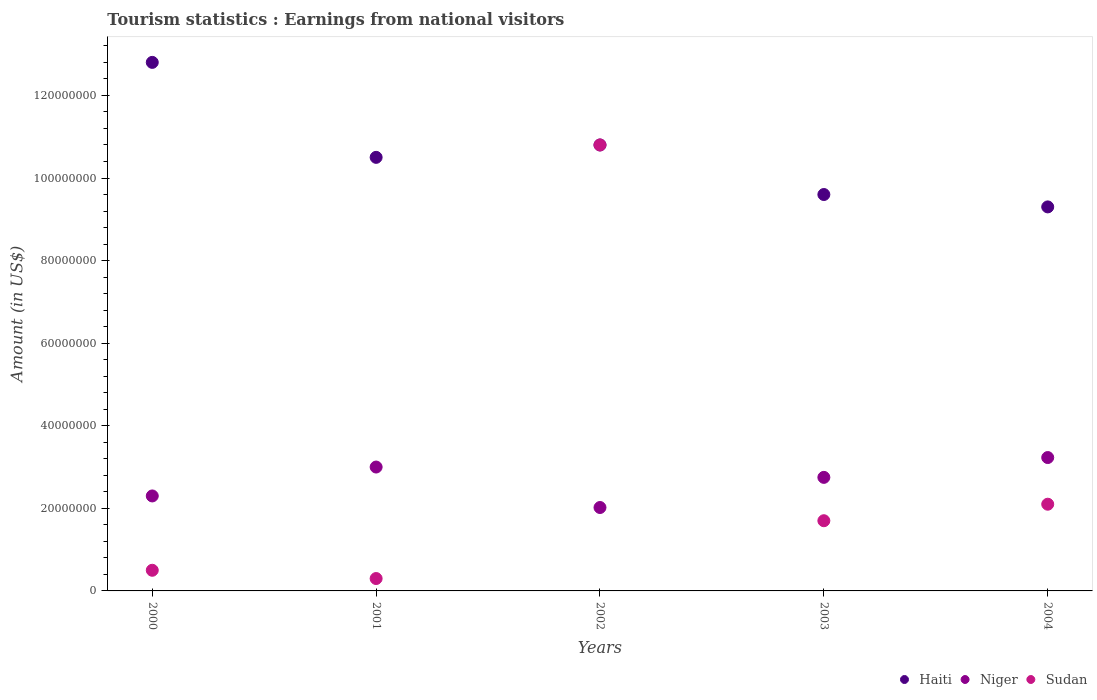How many different coloured dotlines are there?
Your response must be concise. 3. What is the earnings from national visitors in Haiti in 2000?
Provide a short and direct response. 1.28e+08. Across all years, what is the maximum earnings from national visitors in Niger?
Offer a very short reply. 3.23e+07. Across all years, what is the minimum earnings from national visitors in Haiti?
Your answer should be very brief. 9.30e+07. In which year was the earnings from national visitors in Niger maximum?
Your answer should be very brief. 2004. What is the total earnings from national visitors in Sudan in the graph?
Ensure brevity in your answer.  1.54e+08. What is the difference between the earnings from national visitors in Haiti in 2001 and that in 2004?
Give a very brief answer. 1.20e+07. What is the difference between the earnings from national visitors in Haiti in 2004 and the earnings from national visitors in Niger in 2000?
Keep it short and to the point. 7.00e+07. What is the average earnings from national visitors in Sudan per year?
Give a very brief answer. 3.08e+07. In the year 2002, what is the difference between the earnings from national visitors in Sudan and earnings from national visitors in Haiti?
Make the answer very short. 0. What is the ratio of the earnings from national visitors in Sudan in 2002 to that in 2004?
Your response must be concise. 5.14. Is the difference between the earnings from national visitors in Sudan in 2001 and 2003 greater than the difference between the earnings from national visitors in Haiti in 2001 and 2003?
Your answer should be compact. No. What is the difference between the highest and the second highest earnings from national visitors in Sudan?
Offer a very short reply. 8.70e+07. What is the difference between the highest and the lowest earnings from national visitors in Sudan?
Provide a succinct answer. 1.05e+08. In how many years, is the earnings from national visitors in Sudan greater than the average earnings from national visitors in Sudan taken over all years?
Offer a terse response. 1. Is the sum of the earnings from national visitors in Sudan in 2002 and 2003 greater than the maximum earnings from national visitors in Haiti across all years?
Your response must be concise. No. Is it the case that in every year, the sum of the earnings from national visitors in Haiti and earnings from national visitors in Sudan  is greater than the earnings from national visitors in Niger?
Provide a short and direct response. Yes. Does the earnings from national visitors in Haiti monotonically increase over the years?
Give a very brief answer. No. Is the earnings from national visitors in Sudan strictly greater than the earnings from national visitors in Niger over the years?
Provide a short and direct response. No. How many dotlines are there?
Keep it short and to the point. 3. How many years are there in the graph?
Your response must be concise. 5. Are the values on the major ticks of Y-axis written in scientific E-notation?
Ensure brevity in your answer.  No. Does the graph contain any zero values?
Keep it short and to the point. No. Does the graph contain grids?
Provide a short and direct response. No. How many legend labels are there?
Make the answer very short. 3. What is the title of the graph?
Keep it short and to the point. Tourism statistics : Earnings from national visitors. What is the label or title of the X-axis?
Provide a succinct answer. Years. What is the label or title of the Y-axis?
Give a very brief answer. Amount (in US$). What is the Amount (in US$) of Haiti in 2000?
Your response must be concise. 1.28e+08. What is the Amount (in US$) of Niger in 2000?
Your answer should be compact. 2.30e+07. What is the Amount (in US$) of Haiti in 2001?
Keep it short and to the point. 1.05e+08. What is the Amount (in US$) of Niger in 2001?
Offer a very short reply. 3.00e+07. What is the Amount (in US$) in Sudan in 2001?
Give a very brief answer. 3.00e+06. What is the Amount (in US$) of Haiti in 2002?
Give a very brief answer. 1.08e+08. What is the Amount (in US$) in Niger in 2002?
Provide a succinct answer. 2.02e+07. What is the Amount (in US$) of Sudan in 2002?
Ensure brevity in your answer.  1.08e+08. What is the Amount (in US$) in Haiti in 2003?
Your response must be concise. 9.60e+07. What is the Amount (in US$) of Niger in 2003?
Give a very brief answer. 2.75e+07. What is the Amount (in US$) in Sudan in 2003?
Make the answer very short. 1.70e+07. What is the Amount (in US$) in Haiti in 2004?
Keep it short and to the point. 9.30e+07. What is the Amount (in US$) in Niger in 2004?
Offer a terse response. 3.23e+07. What is the Amount (in US$) in Sudan in 2004?
Your answer should be compact. 2.10e+07. Across all years, what is the maximum Amount (in US$) of Haiti?
Ensure brevity in your answer.  1.28e+08. Across all years, what is the maximum Amount (in US$) of Niger?
Your answer should be compact. 3.23e+07. Across all years, what is the maximum Amount (in US$) in Sudan?
Your answer should be very brief. 1.08e+08. Across all years, what is the minimum Amount (in US$) of Haiti?
Your answer should be very brief. 9.30e+07. Across all years, what is the minimum Amount (in US$) of Niger?
Your answer should be compact. 2.02e+07. What is the total Amount (in US$) in Haiti in the graph?
Your answer should be very brief. 5.30e+08. What is the total Amount (in US$) of Niger in the graph?
Make the answer very short. 1.33e+08. What is the total Amount (in US$) of Sudan in the graph?
Your answer should be compact. 1.54e+08. What is the difference between the Amount (in US$) in Haiti in 2000 and that in 2001?
Provide a succinct answer. 2.30e+07. What is the difference between the Amount (in US$) of Niger in 2000 and that in 2001?
Make the answer very short. -7.00e+06. What is the difference between the Amount (in US$) in Sudan in 2000 and that in 2001?
Provide a short and direct response. 2.00e+06. What is the difference between the Amount (in US$) in Haiti in 2000 and that in 2002?
Give a very brief answer. 2.00e+07. What is the difference between the Amount (in US$) in Niger in 2000 and that in 2002?
Ensure brevity in your answer.  2.80e+06. What is the difference between the Amount (in US$) of Sudan in 2000 and that in 2002?
Your response must be concise. -1.03e+08. What is the difference between the Amount (in US$) in Haiti in 2000 and that in 2003?
Make the answer very short. 3.20e+07. What is the difference between the Amount (in US$) of Niger in 2000 and that in 2003?
Offer a terse response. -4.50e+06. What is the difference between the Amount (in US$) in Sudan in 2000 and that in 2003?
Provide a short and direct response. -1.20e+07. What is the difference between the Amount (in US$) in Haiti in 2000 and that in 2004?
Offer a terse response. 3.50e+07. What is the difference between the Amount (in US$) of Niger in 2000 and that in 2004?
Offer a terse response. -9.30e+06. What is the difference between the Amount (in US$) in Sudan in 2000 and that in 2004?
Provide a succinct answer. -1.60e+07. What is the difference between the Amount (in US$) in Haiti in 2001 and that in 2002?
Provide a short and direct response. -3.00e+06. What is the difference between the Amount (in US$) of Niger in 2001 and that in 2002?
Keep it short and to the point. 9.80e+06. What is the difference between the Amount (in US$) of Sudan in 2001 and that in 2002?
Offer a very short reply. -1.05e+08. What is the difference between the Amount (in US$) of Haiti in 2001 and that in 2003?
Your response must be concise. 9.00e+06. What is the difference between the Amount (in US$) of Niger in 2001 and that in 2003?
Provide a succinct answer. 2.50e+06. What is the difference between the Amount (in US$) of Sudan in 2001 and that in 2003?
Ensure brevity in your answer.  -1.40e+07. What is the difference between the Amount (in US$) in Niger in 2001 and that in 2004?
Provide a succinct answer. -2.30e+06. What is the difference between the Amount (in US$) in Sudan in 2001 and that in 2004?
Your response must be concise. -1.80e+07. What is the difference between the Amount (in US$) of Haiti in 2002 and that in 2003?
Make the answer very short. 1.20e+07. What is the difference between the Amount (in US$) in Niger in 2002 and that in 2003?
Your answer should be very brief. -7.30e+06. What is the difference between the Amount (in US$) in Sudan in 2002 and that in 2003?
Give a very brief answer. 9.10e+07. What is the difference between the Amount (in US$) of Haiti in 2002 and that in 2004?
Your answer should be very brief. 1.50e+07. What is the difference between the Amount (in US$) of Niger in 2002 and that in 2004?
Give a very brief answer. -1.21e+07. What is the difference between the Amount (in US$) in Sudan in 2002 and that in 2004?
Your answer should be very brief. 8.70e+07. What is the difference between the Amount (in US$) in Haiti in 2003 and that in 2004?
Provide a short and direct response. 3.00e+06. What is the difference between the Amount (in US$) in Niger in 2003 and that in 2004?
Keep it short and to the point. -4.80e+06. What is the difference between the Amount (in US$) in Sudan in 2003 and that in 2004?
Offer a very short reply. -4.00e+06. What is the difference between the Amount (in US$) in Haiti in 2000 and the Amount (in US$) in Niger in 2001?
Provide a succinct answer. 9.80e+07. What is the difference between the Amount (in US$) in Haiti in 2000 and the Amount (in US$) in Sudan in 2001?
Keep it short and to the point. 1.25e+08. What is the difference between the Amount (in US$) of Haiti in 2000 and the Amount (in US$) of Niger in 2002?
Provide a succinct answer. 1.08e+08. What is the difference between the Amount (in US$) of Niger in 2000 and the Amount (in US$) of Sudan in 2002?
Keep it short and to the point. -8.50e+07. What is the difference between the Amount (in US$) in Haiti in 2000 and the Amount (in US$) in Niger in 2003?
Offer a terse response. 1.00e+08. What is the difference between the Amount (in US$) in Haiti in 2000 and the Amount (in US$) in Sudan in 2003?
Your answer should be very brief. 1.11e+08. What is the difference between the Amount (in US$) in Haiti in 2000 and the Amount (in US$) in Niger in 2004?
Ensure brevity in your answer.  9.57e+07. What is the difference between the Amount (in US$) of Haiti in 2000 and the Amount (in US$) of Sudan in 2004?
Ensure brevity in your answer.  1.07e+08. What is the difference between the Amount (in US$) of Haiti in 2001 and the Amount (in US$) of Niger in 2002?
Give a very brief answer. 8.48e+07. What is the difference between the Amount (in US$) of Haiti in 2001 and the Amount (in US$) of Sudan in 2002?
Your answer should be compact. -3.00e+06. What is the difference between the Amount (in US$) in Niger in 2001 and the Amount (in US$) in Sudan in 2002?
Provide a short and direct response. -7.80e+07. What is the difference between the Amount (in US$) of Haiti in 2001 and the Amount (in US$) of Niger in 2003?
Your response must be concise. 7.75e+07. What is the difference between the Amount (in US$) of Haiti in 2001 and the Amount (in US$) of Sudan in 2003?
Your answer should be compact. 8.80e+07. What is the difference between the Amount (in US$) in Niger in 2001 and the Amount (in US$) in Sudan in 2003?
Offer a terse response. 1.30e+07. What is the difference between the Amount (in US$) of Haiti in 2001 and the Amount (in US$) of Niger in 2004?
Give a very brief answer. 7.27e+07. What is the difference between the Amount (in US$) in Haiti in 2001 and the Amount (in US$) in Sudan in 2004?
Your response must be concise. 8.40e+07. What is the difference between the Amount (in US$) of Niger in 2001 and the Amount (in US$) of Sudan in 2004?
Offer a very short reply. 9.00e+06. What is the difference between the Amount (in US$) in Haiti in 2002 and the Amount (in US$) in Niger in 2003?
Give a very brief answer. 8.05e+07. What is the difference between the Amount (in US$) of Haiti in 2002 and the Amount (in US$) of Sudan in 2003?
Make the answer very short. 9.10e+07. What is the difference between the Amount (in US$) of Niger in 2002 and the Amount (in US$) of Sudan in 2003?
Make the answer very short. 3.20e+06. What is the difference between the Amount (in US$) of Haiti in 2002 and the Amount (in US$) of Niger in 2004?
Offer a very short reply. 7.57e+07. What is the difference between the Amount (in US$) in Haiti in 2002 and the Amount (in US$) in Sudan in 2004?
Offer a terse response. 8.70e+07. What is the difference between the Amount (in US$) in Niger in 2002 and the Amount (in US$) in Sudan in 2004?
Provide a succinct answer. -8.00e+05. What is the difference between the Amount (in US$) in Haiti in 2003 and the Amount (in US$) in Niger in 2004?
Offer a very short reply. 6.37e+07. What is the difference between the Amount (in US$) in Haiti in 2003 and the Amount (in US$) in Sudan in 2004?
Give a very brief answer. 7.50e+07. What is the difference between the Amount (in US$) of Niger in 2003 and the Amount (in US$) of Sudan in 2004?
Provide a succinct answer. 6.50e+06. What is the average Amount (in US$) of Haiti per year?
Provide a succinct answer. 1.06e+08. What is the average Amount (in US$) in Niger per year?
Your response must be concise. 2.66e+07. What is the average Amount (in US$) of Sudan per year?
Provide a succinct answer. 3.08e+07. In the year 2000, what is the difference between the Amount (in US$) of Haiti and Amount (in US$) of Niger?
Provide a succinct answer. 1.05e+08. In the year 2000, what is the difference between the Amount (in US$) in Haiti and Amount (in US$) in Sudan?
Offer a terse response. 1.23e+08. In the year 2000, what is the difference between the Amount (in US$) of Niger and Amount (in US$) of Sudan?
Your response must be concise. 1.80e+07. In the year 2001, what is the difference between the Amount (in US$) in Haiti and Amount (in US$) in Niger?
Make the answer very short. 7.50e+07. In the year 2001, what is the difference between the Amount (in US$) of Haiti and Amount (in US$) of Sudan?
Your answer should be compact. 1.02e+08. In the year 2001, what is the difference between the Amount (in US$) of Niger and Amount (in US$) of Sudan?
Keep it short and to the point. 2.70e+07. In the year 2002, what is the difference between the Amount (in US$) in Haiti and Amount (in US$) in Niger?
Give a very brief answer. 8.78e+07. In the year 2002, what is the difference between the Amount (in US$) of Niger and Amount (in US$) of Sudan?
Provide a short and direct response. -8.78e+07. In the year 2003, what is the difference between the Amount (in US$) of Haiti and Amount (in US$) of Niger?
Make the answer very short. 6.85e+07. In the year 2003, what is the difference between the Amount (in US$) of Haiti and Amount (in US$) of Sudan?
Provide a succinct answer. 7.90e+07. In the year 2003, what is the difference between the Amount (in US$) of Niger and Amount (in US$) of Sudan?
Ensure brevity in your answer.  1.05e+07. In the year 2004, what is the difference between the Amount (in US$) in Haiti and Amount (in US$) in Niger?
Ensure brevity in your answer.  6.07e+07. In the year 2004, what is the difference between the Amount (in US$) in Haiti and Amount (in US$) in Sudan?
Your response must be concise. 7.20e+07. In the year 2004, what is the difference between the Amount (in US$) in Niger and Amount (in US$) in Sudan?
Ensure brevity in your answer.  1.13e+07. What is the ratio of the Amount (in US$) in Haiti in 2000 to that in 2001?
Your answer should be very brief. 1.22. What is the ratio of the Amount (in US$) in Niger in 2000 to that in 2001?
Keep it short and to the point. 0.77. What is the ratio of the Amount (in US$) in Sudan in 2000 to that in 2001?
Your answer should be very brief. 1.67. What is the ratio of the Amount (in US$) of Haiti in 2000 to that in 2002?
Offer a terse response. 1.19. What is the ratio of the Amount (in US$) of Niger in 2000 to that in 2002?
Provide a short and direct response. 1.14. What is the ratio of the Amount (in US$) of Sudan in 2000 to that in 2002?
Your answer should be compact. 0.05. What is the ratio of the Amount (in US$) in Niger in 2000 to that in 2003?
Keep it short and to the point. 0.84. What is the ratio of the Amount (in US$) in Sudan in 2000 to that in 2003?
Offer a terse response. 0.29. What is the ratio of the Amount (in US$) in Haiti in 2000 to that in 2004?
Offer a terse response. 1.38. What is the ratio of the Amount (in US$) in Niger in 2000 to that in 2004?
Offer a very short reply. 0.71. What is the ratio of the Amount (in US$) in Sudan in 2000 to that in 2004?
Provide a succinct answer. 0.24. What is the ratio of the Amount (in US$) of Haiti in 2001 to that in 2002?
Give a very brief answer. 0.97. What is the ratio of the Amount (in US$) in Niger in 2001 to that in 2002?
Ensure brevity in your answer.  1.49. What is the ratio of the Amount (in US$) in Sudan in 2001 to that in 2002?
Your answer should be compact. 0.03. What is the ratio of the Amount (in US$) in Haiti in 2001 to that in 2003?
Provide a succinct answer. 1.09. What is the ratio of the Amount (in US$) in Sudan in 2001 to that in 2003?
Your answer should be compact. 0.18. What is the ratio of the Amount (in US$) of Haiti in 2001 to that in 2004?
Your response must be concise. 1.13. What is the ratio of the Amount (in US$) in Niger in 2001 to that in 2004?
Provide a short and direct response. 0.93. What is the ratio of the Amount (in US$) of Sudan in 2001 to that in 2004?
Provide a succinct answer. 0.14. What is the ratio of the Amount (in US$) in Niger in 2002 to that in 2003?
Keep it short and to the point. 0.73. What is the ratio of the Amount (in US$) of Sudan in 2002 to that in 2003?
Provide a short and direct response. 6.35. What is the ratio of the Amount (in US$) in Haiti in 2002 to that in 2004?
Keep it short and to the point. 1.16. What is the ratio of the Amount (in US$) in Niger in 2002 to that in 2004?
Give a very brief answer. 0.63. What is the ratio of the Amount (in US$) of Sudan in 2002 to that in 2004?
Ensure brevity in your answer.  5.14. What is the ratio of the Amount (in US$) of Haiti in 2003 to that in 2004?
Provide a succinct answer. 1.03. What is the ratio of the Amount (in US$) in Niger in 2003 to that in 2004?
Give a very brief answer. 0.85. What is the ratio of the Amount (in US$) of Sudan in 2003 to that in 2004?
Keep it short and to the point. 0.81. What is the difference between the highest and the second highest Amount (in US$) in Haiti?
Your answer should be very brief. 2.00e+07. What is the difference between the highest and the second highest Amount (in US$) in Niger?
Provide a succinct answer. 2.30e+06. What is the difference between the highest and the second highest Amount (in US$) of Sudan?
Your answer should be very brief. 8.70e+07. What is the difference between the highest and the lowest Amount (in US$) of Haiti?
Make the answer very short. 3.50e+07. What is the difference between the highest and the lowest Amount (in US$) in Niger?
Provide a succinct answer. 1.21e+07. What is the difference between the highest and the lowest Amount (in US$) of Sudan?
Provide a succinct answer. 1.05e+08. 